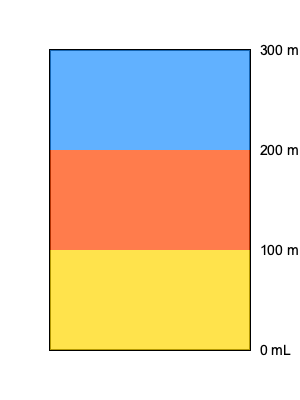In a popular layered cocktail served at a Rochester bar, the bartender uses a graduated cylinder to measure the ingredients. The bottom layer is Goldschläger (gold), the middle layer is Fireball Cinnamon Whisky (red), and the top layer is Blue Curaçao (blue). If the total volume of the cocktail is 300 mL and the ratio of Goldschläger to Fireball to Blue Curaçao is 1:1:1, what is the volume of each ingredient in mL? To solve this problem, we'll follow these steps:

1. Understand the given information:
   - The total volume of the cocktail is 300 mL
   - The ratio of Goldschläger : Fireball : Blue Curaçao is 1:1:1
   - We need to find the volume of each ingredient

2. Calculate the number of parts in the ratio:
   1 + 1 + 1 = 3 parts total

3. Calculate the volume of each part:
   Total volume ÷ Total parts = Volume per part
   $\frac{300 \text{ mL}}{3} = 100 \text{ mL}$ per part

4. Assign the volume to each ingredient:
   - Goldschläger (bottom layer): 1 part = 100 mL
   - Fireball (middle layer): 1 part = 100 mL
   - Blue Curaçao (top layer): 1 part = 100 mL

5. Verify the total:
   100 mL + 100 mL + 100 mL = 300 mL (which matches the given total volume)

Therefore, each ingredient in the layered cocktail has a volume of 100 mL.
Answer: 100 mL each 